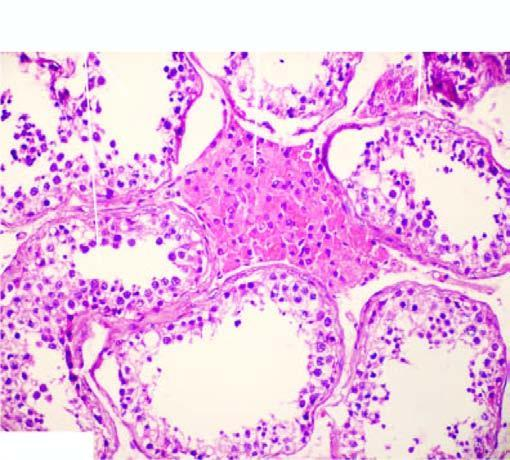s there prominence of leydig cells in the interstitium?
Answer the question using a single word or phrase. Yes 